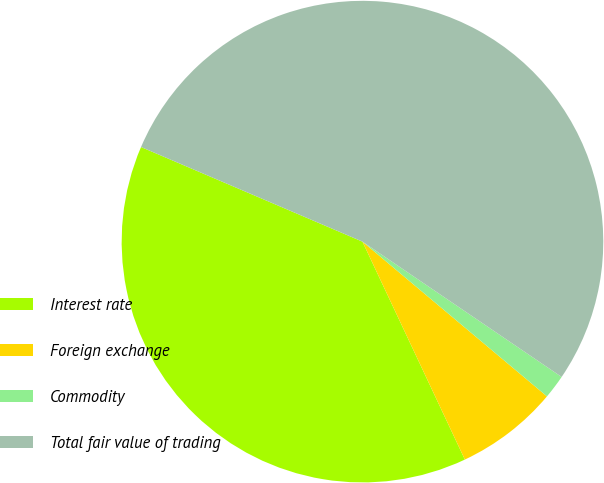<chart> <loc_0><loc_0><loc_500><loc_500><pie_chart><fcel>Interest rate<fcel>Foreign exchange<fcel>Commodity<fcel>Total fair value of trading<nl><fcel>38.42%<fcel>6.9%<fcel>1.61%<fcel>53.07%<nl></chart> 